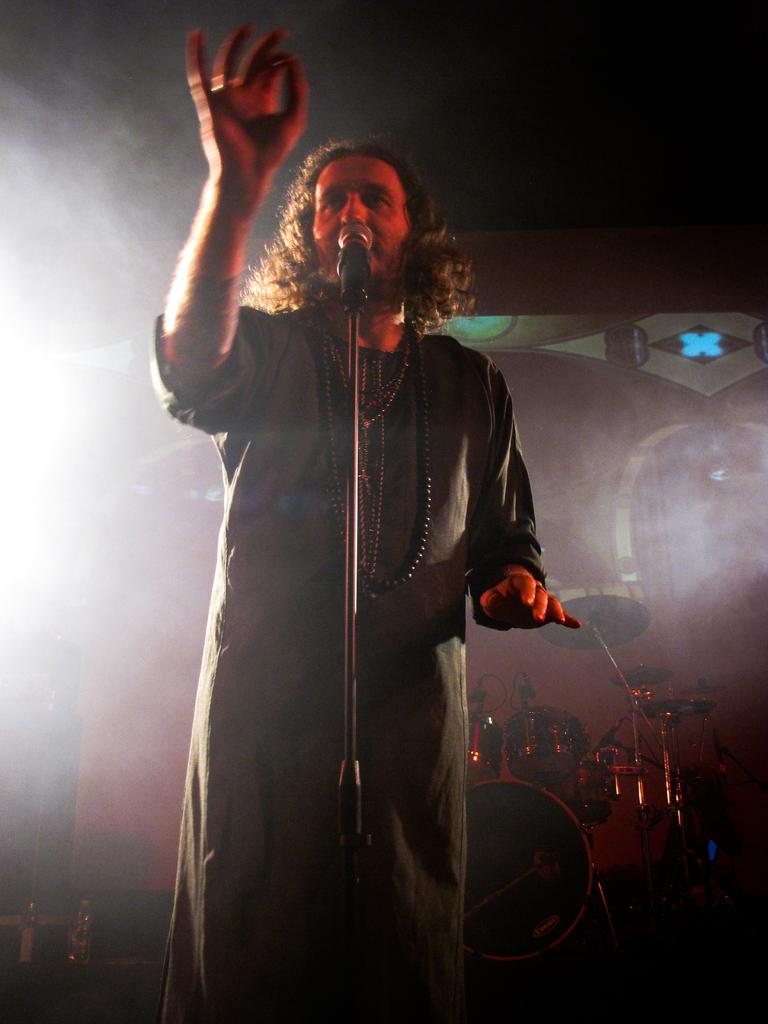Who is the main subject in the image? There is a man in the picture. Where is the man positioned in the image? The man is standing in the middle of the picture. What is the man doing in the image? The man is in front of a mic. What can be observed about the background of the image? The background of the image is dark. Can you describe the lighting in the image? There is a white color light on the left side of the image. What type of fear does the man show in the image? The image does not show any fear; the man is standing in front of a mic. What action is the man taking in the shop in the image? There is no shop present in the image, and the man is not taking any action besides standing in front of a mic. 